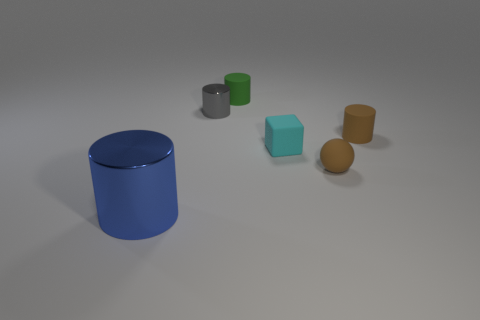What number of other things have the same shape as the green rubber object?
Give a very brief answer. 3. Do the big shiny thing and the tiny object that is on the left side of the small green cylinder have the same shape?
Provide a succinct answer. Yes. There is a small object that is the same color as the tiny ball; what is its shape?
Offer a terse response. Cylinder. Is there a large block that has the same material as the small cyan thing?
Provide a succinct answer. No. Are there any other things that are the same material as the large blue object?
Your answer should be compact. Yes. There is a small cylinder that is right of the small cylinder behind the gray metal cylinder; what is it made of?
Offer a very short reply. Rubber. What is the size of the matte cylinder left of the small rubber thing that is in front of the cyan thing behind the brown ball?
Your answer should be compact. Small. What number of other objects are the same shape as the tiny green rubber thing?
Offer a terse response. 3. Does the metallic cylinder behind the small brown rubber sphere have the same color as the small cylinder that is behind the gray metallic object?
Your answer should be compact. No. There is a shiny thing that is the same size as the brown sphere; what color is it?
Provide a succinct answer. Gray. 